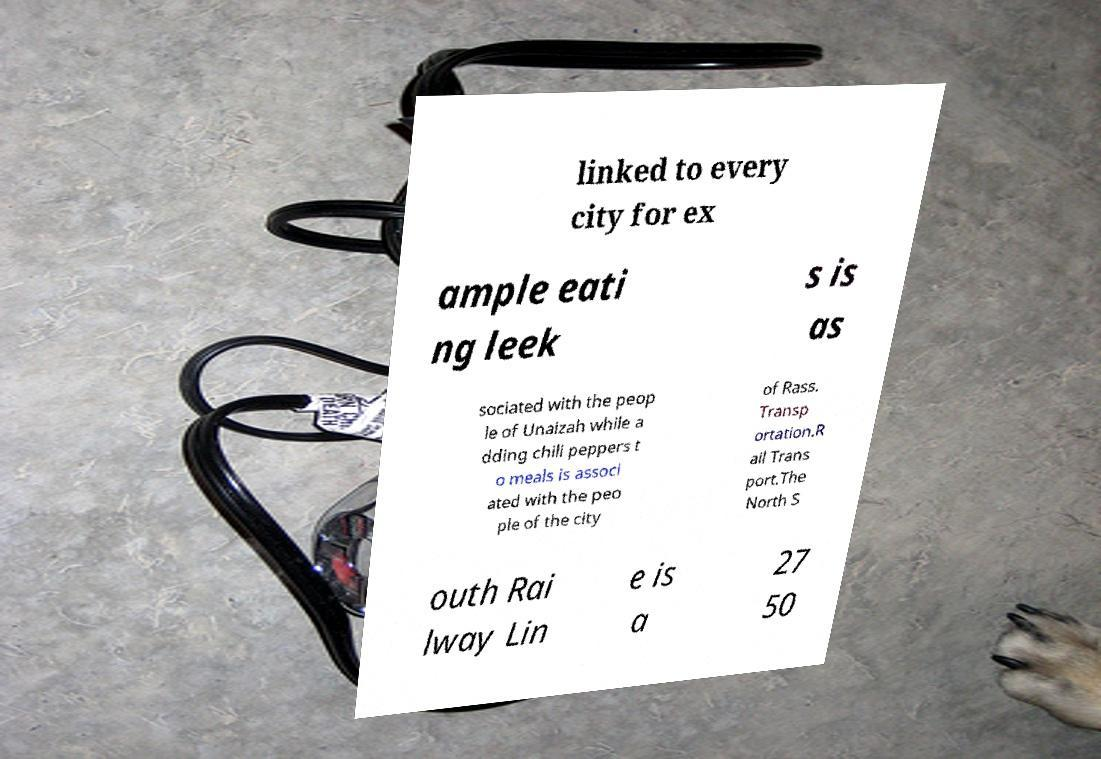What messages or text are displayed in this image? I need them in a readable, typed format. linked to every city for ex ample eati ng leek s is as sociated with the peop le of Unaizah while a dding chili peppers t o meals is associ ated with the peo ple of the city of Rass. Transp ortation.R ail Trans port.The North S outh Rai lway Lin e is a 27 50 